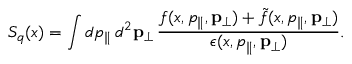Convert formula to latex. <formula><loc_0><loc_0><loc_500><loc_500>S _ { q } ( x ) = \int d p _ { \| } \, d ^ { 2 } { p } _ { \perp } \, \frac { f ( x , p _ { \| } , { p } _ { \perp } ) + \tilde { f } ( x , p _ { \| } , { p } _ { \perp } ) } { \epsilon ( x , p _ { \| } , { p } _ { \perp } ) } .</formula> 